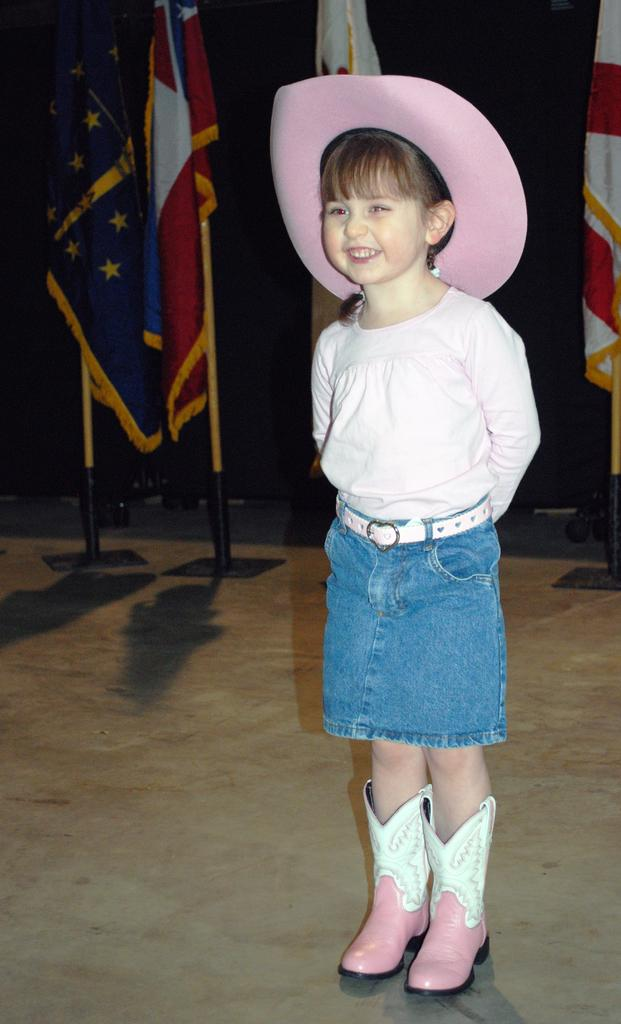What is the main subject of the image? There is a kid standing in the image. What is the kid wearing? The kid is wearing a white dress. Where is the kid located in the image? The kid is on the right side of the image. What can be seen in the background of the image? There are flags in the background of the image. What type of joke is the kid telling in the image? There is no indication in the image that the kid is telling a joke, so it cannot be determined from the picture. 